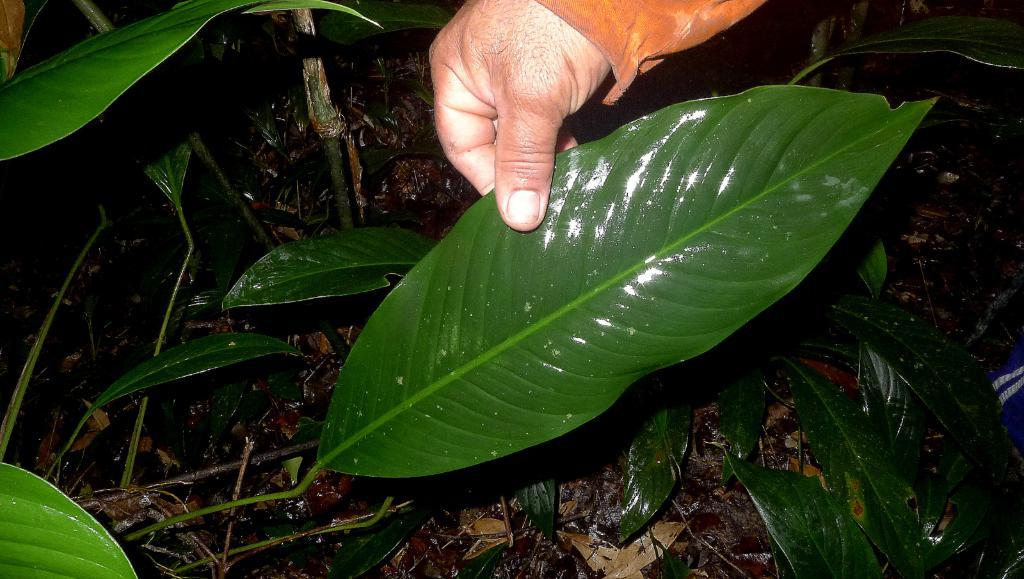What is the person's hand holding in the image? The person's hand is holding a leaf in the image. Are there any other leaves visible in the image? Yes, there are additional leaves around the leaf being held. What is the condition of the leaves on the surface in the image? The leaves on the surface are dry. What type of noise is the dog making in the image? There is no dog present in the image, so it is not possible to determine what noise the dog might be making. 